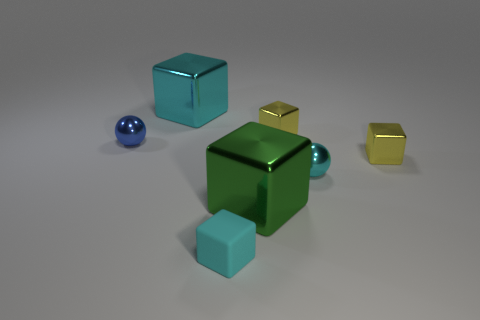There is a metal sphere that is the same color as the tiny matte block; what size is it?
Offer a very short reply. Small. Are there any other small blue balls made of the same material as the tiny blue sphere?
Your answer should be compact. No. There is a cyan block behind the matte block; what is it made of?
Ensure brevity in your answer.  Metal. Do the big block that is to the left of the green object and the thing to the left of the cyan metallic block have the same color?
Your response must be concise. No. There is a shiny thing that is the same size as the cyan shiny cube; what color is it?
Give a very brief answer. Green. How many other things are the same shape as the tiny rubber thing?
Make the answer very short. 4. What is the size of the block that is in front of the green object?
Make the answer very short. Small. How many small shiny blocks are behind the yellow object that is behind the blue metallic object?
Offer a very short reply. 0. How many other objects are there of the same size as the green shiny thing?
Keep it short and to the point. 1. There is a small shiny thing that is behind the blue metallic thing; is its shape the same as the green thing?
Keep it short and to the point. Yes. 